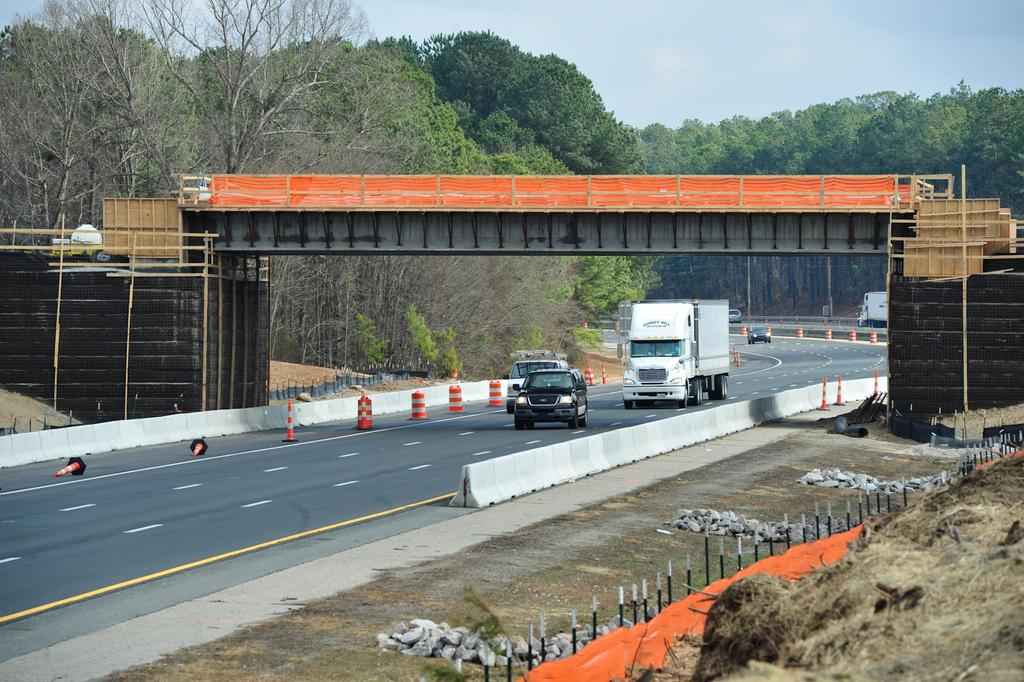What structure can be seen in the image? There is a bridge in the image. What is happening on the bridge or near it? There are vehicles on the road in the image. What type of natural elements can be seen in the image? There are trees visible in the image. What is visible at the top of the image? The sky is visible at the top of the image. How many marks are visible on the bridge in the image? There are no marks mentioned or visible on the bridge in the image. What type of clam can be seen crawling on the road in the image? There are no clams present in the image; it features a bridge, vehicles, trees, and the sky. 